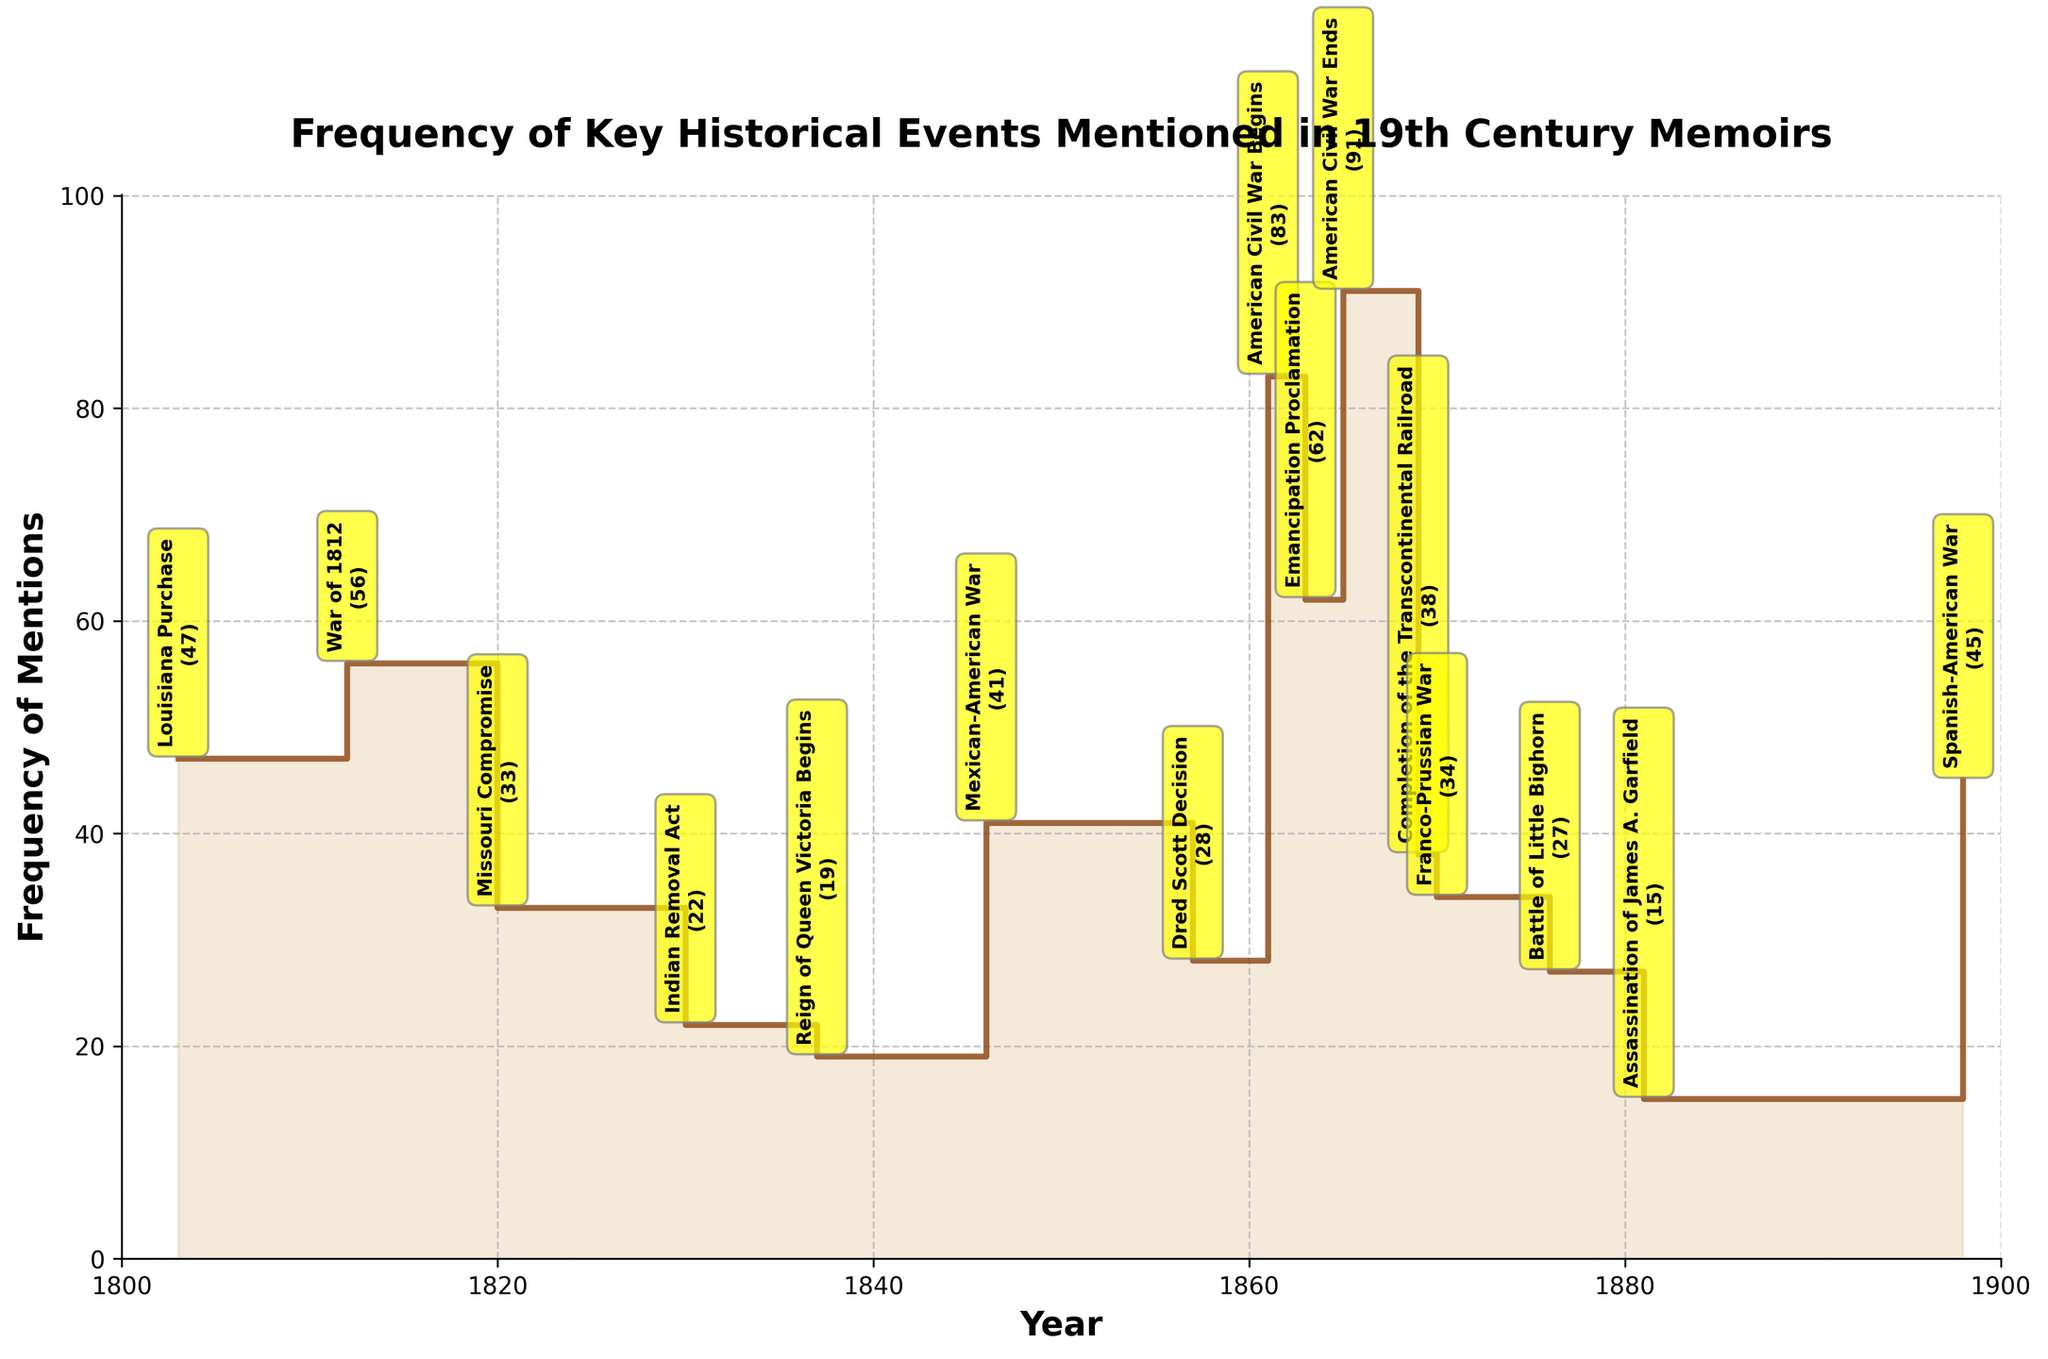what is the time range displayed in the plot? The x-axis of the plot is labeled 'Year' and spans from 1800 to 1900. Hence, the plot encompasses the entire 19th century.
Answer: 1800 to 1900 Which year had the highest frequency of mentions in the memoirs? From the vertical steps on the plot, the year 1865 stands out with the highest point, indicating that the end of the American Civil War had the highest frequency of mentions.
Answer: 1865 How does the frequency of the mention of War of 1812 compare to the frequency of the mention of the Reign of Queen Victoria Begins? The frequency of the War of 1812, which is 56, is compared to 19 for the Reign of Queen Victoria Begins, meaning the War of 1812 had more mentions.
Answer: War of 1812 had more mentions What is the difference in mentions between the beginning and the end of the American Civil War? The plot shows 83 mentions in 1861 (beginning of the Civil War) and 91 mentions in 1865 (end of the Civil War). The difference is 91 - 83 = 8.
Answer: 8 What is the average frequency of mentions for the events in the 1850s? The plot records 28 (Dred Scott Decision) mentions in 1857. Since it's the only event in the 1850s among given data, the average is 28/1 = 28.
Answer: 28 How does the frequency of mentions of the Emancipation Proclamation compare to the Louisiana Purchase? The frequency for the Emancipation Proclamation in 1863 is 62, and for the Louisiana Purchase in 1803, it is 47. Therefore, the Emancipation Proclamation was mentioned more frequently than the Louisiana Purchase.
Answer: Emancipation Proclamation had more mentions What general trend in frequency can be observed from the periods before and after the American Civil War? Before the American Civil War (prior to 1861), the frequencies are generally lower, with relatively fewer spikes. After the beginning of the Civil War, there are notable higher frequencies, peaking in 1865. This indicates that the period surrounding the Civil War had more mentions.
Answer: Higher mentions after 1861 Among the events listed, which had the lowest frequency of mentions and what might be a reason? The event with the lowest frequency is the Assassination of James A. Garfield in 1881, with only 15 mentions. This might be due to its occurrence relatively late in the century, decreasing its impact on memoirs focused on earlier events.
Answer: Assassination of James A. Garfield What's the cumulative number of mentions for all the historical events listed? Summing up all the counts: 47 + 56 + 33 + 22 + 19 + 41 + 28 + 83 + 62 + 91 + 38 + 34 + 27 + 15 + 45 = 641.
Answer: 641 How does the frequency of mentions for the Indian Removal Act compare to the Battle of Little Bighorn? The Indian Removal Act has a frequency of 22 mentions, whereas the Battle of Little Bighorn has 27 mentions. Therefore, the Battle of Little Bighorn was mentioned more frequently.
Answer: Battle of Little Bighorn had more mentions 